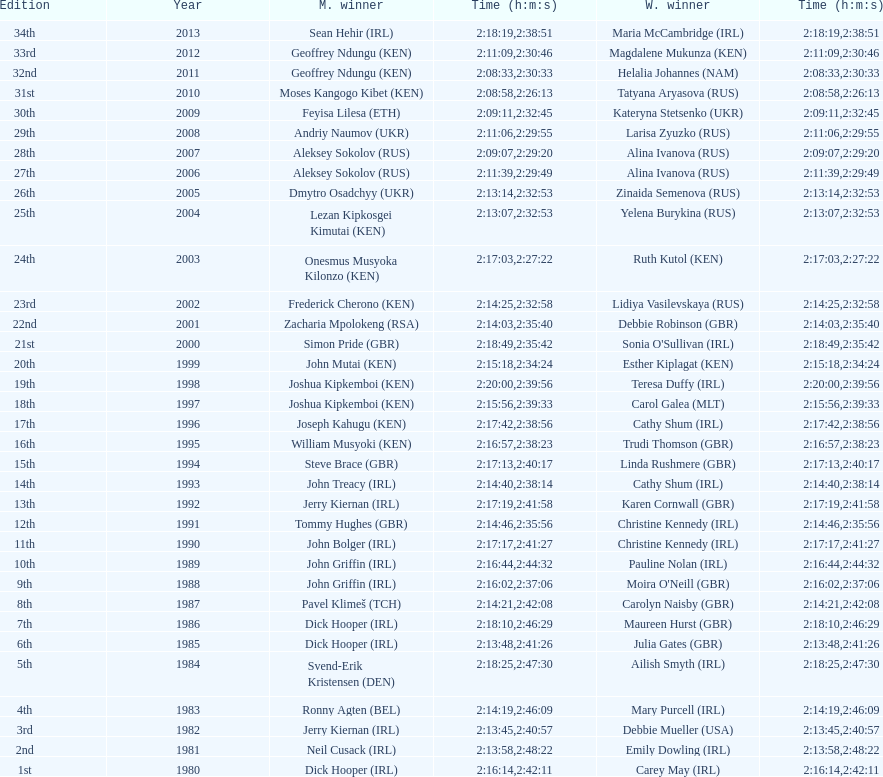Which country is represented for both men and women at the top of the list? Ireland. 